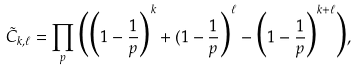Convert formula to latex. <formula><loc_0><loc_0><loc_500><loc_500>\tilde { C } _ { k , \ell } = \prod _ { p } \Big ( \Big ( 1 - \frac { 1 } { p } \Big ) ^ { k } + ( 1 - \frac { 1 } { p } \Big ) ^ { \ell } - \Big ( 1 - \frac { 1 } { p } \Big ) ^ { k + \ell } \Big ) ,</formula> 